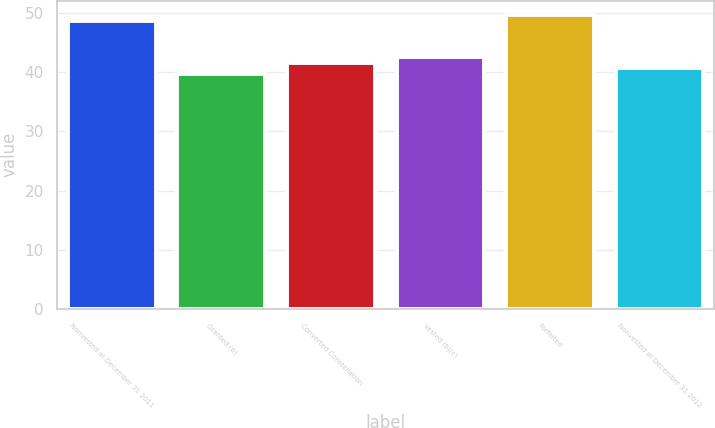<chart> <loc_0><loc_0><loc_500><loc_500><bar_chart><fcel>Nonvested at December 31 2011<fcel>Granted (b)<fcel>Converted Constellation<fcel>Vested (b)(c)<fcel>Forfeited<fcel>Nonvested at December 31 2012<nl><fcel>48.66<fcel>39.66<fcel>41.62<fcel>42.6<fcel>49.64<fcel>40.64<nl></chart> 